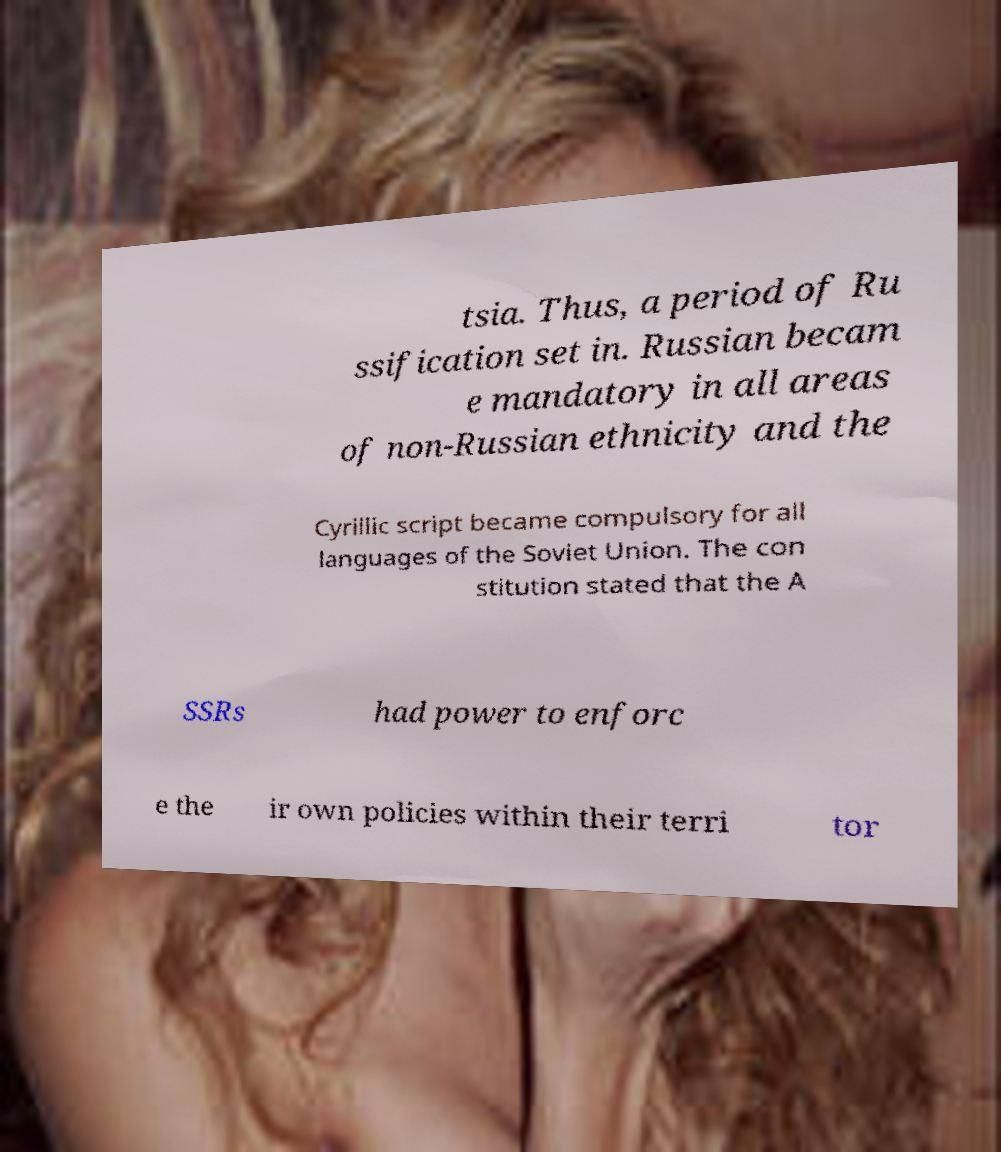Could you assist in decoding the text presented in this image and type it out clearly? tsia. Thus, a period of Ru ssification set in. Russian becam e mandatory in all areas of non-Russian ethnicity and the Cyrillic script became compulsory for all languages of the Soviet Union. The con stitution stated that the A SSRs had power to enforc e the ir own policies within their terri tor 